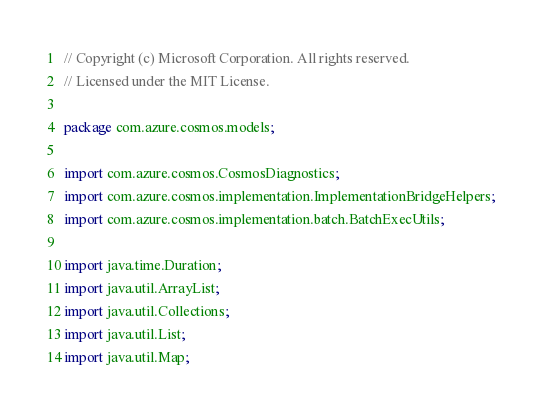<code> <loc_0><loc_0><loc_500><loc_500><_Java_>// Copyright (c) Microsoft Corporation. All rights reserved.
// Licensed under the MIT License.

package com.azure.cosmos.models;

import com.azure.cosmos.CosmosDiagnostics;
import com.azure.cosmos.implementation.ImplementationBridgeHelpers;
import com.azure.cosmos.implementation.batch.BatchExecUtils;

import java.time.Duration;
import java.util.ArrayList;
import java.util.Collections;
import java.util.List;
import java.util.Map;
</code> 